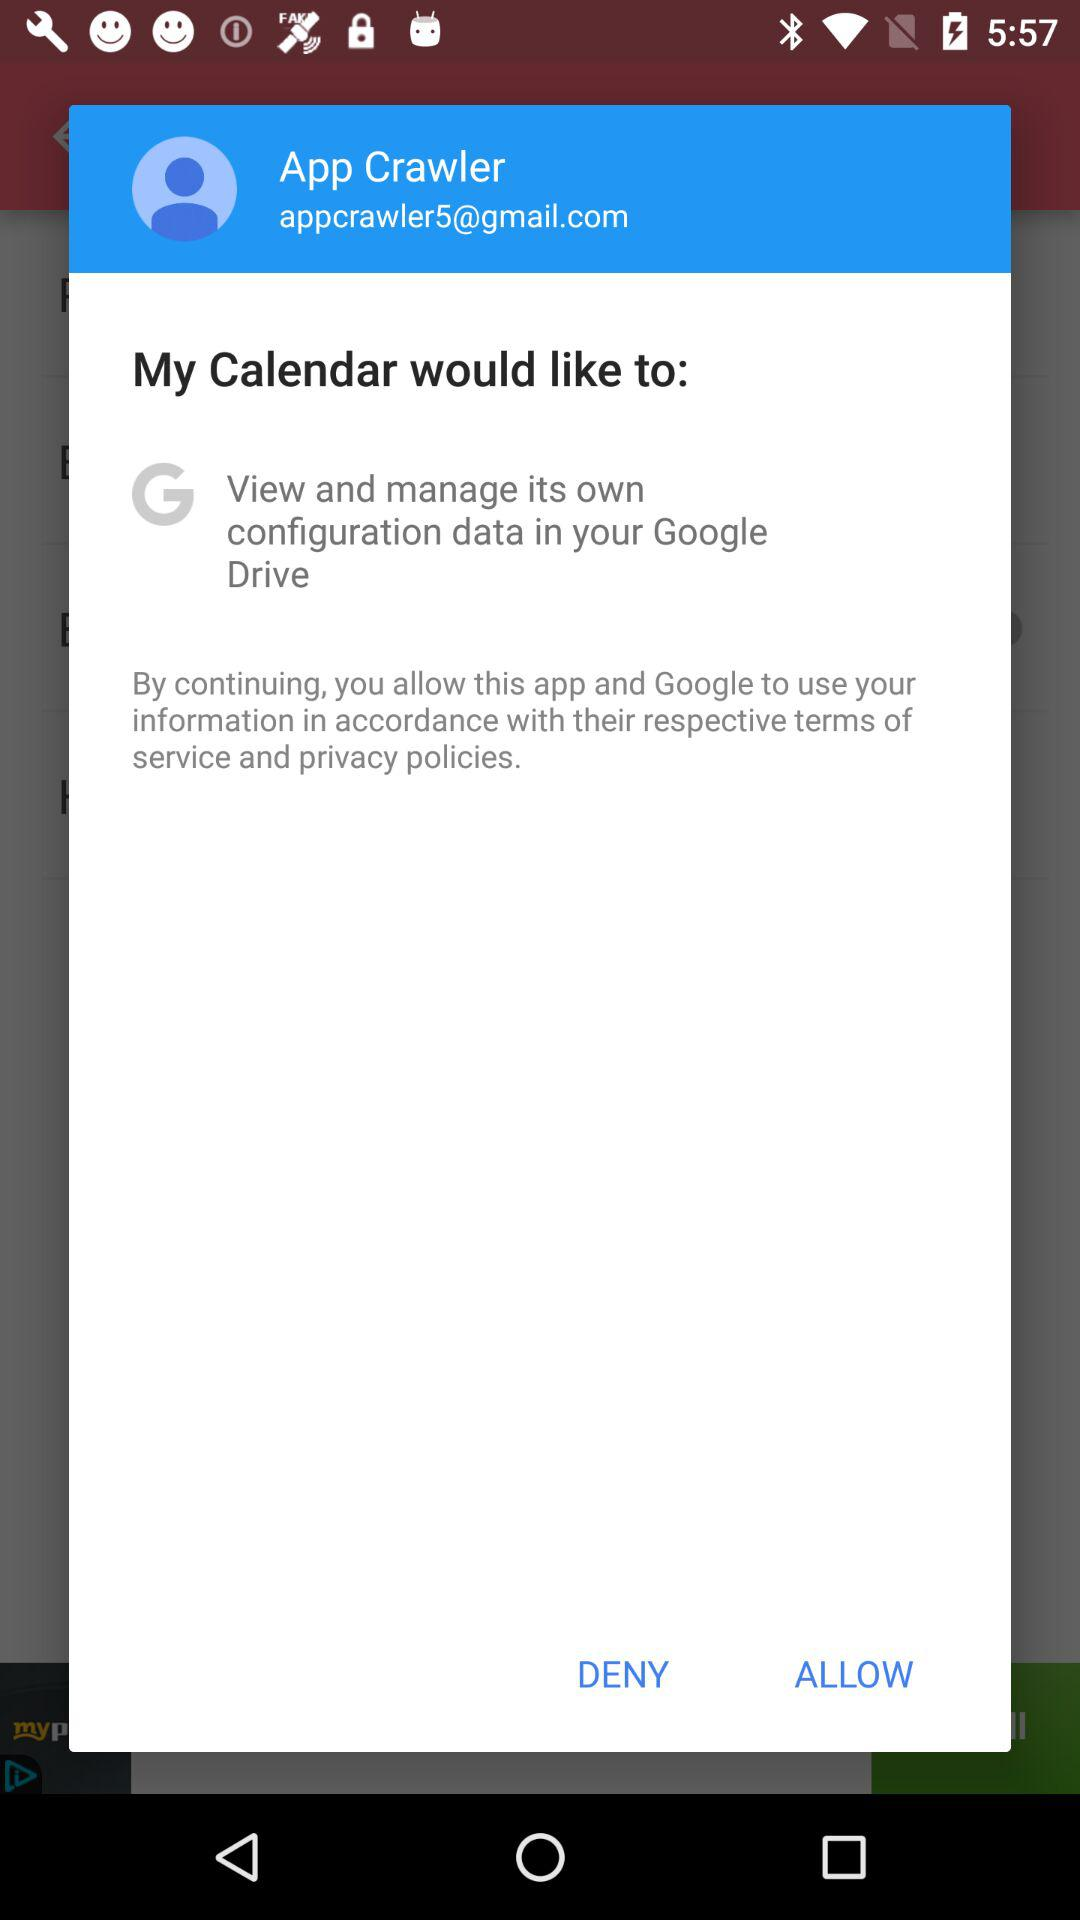Where can you view and manage the configuration data for the calendar? You can view and manage the configuration data on your Google Drive. 